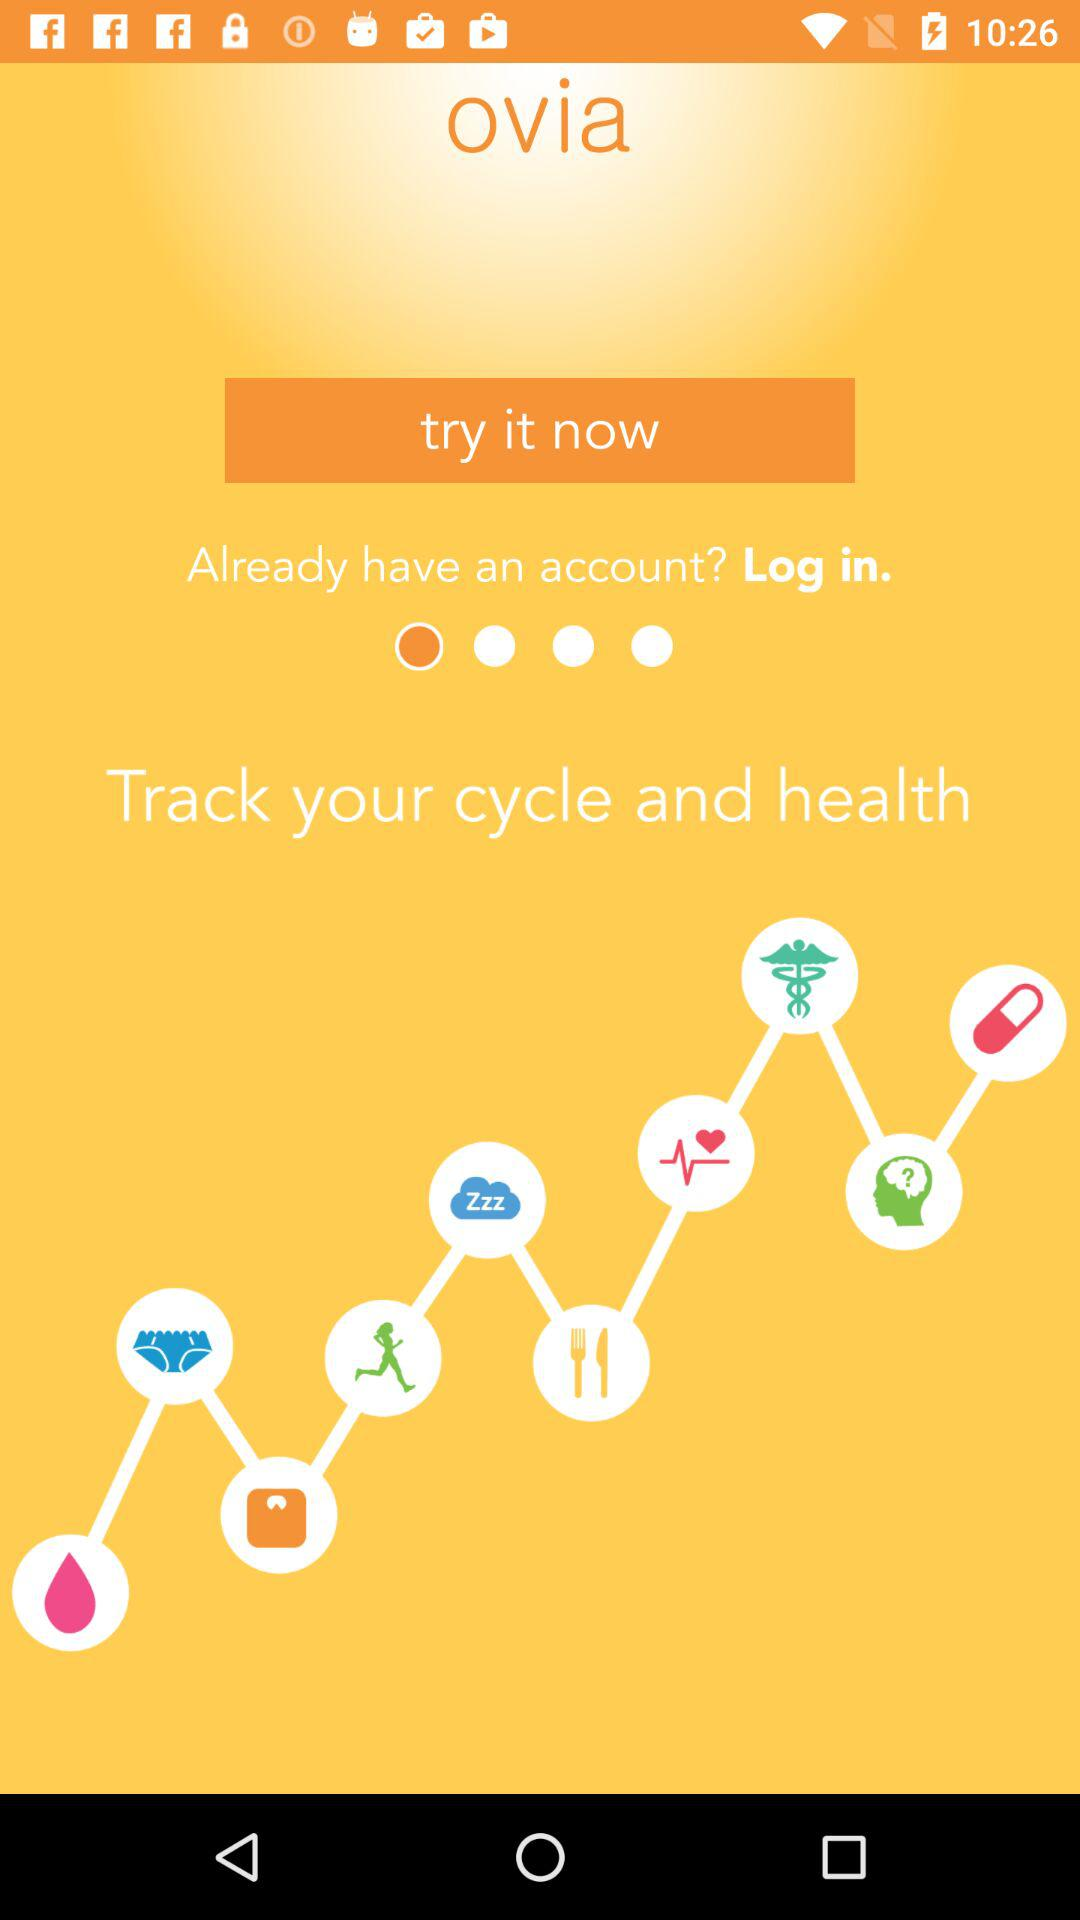What is the name of the application? The name of the application is "Ovia". 